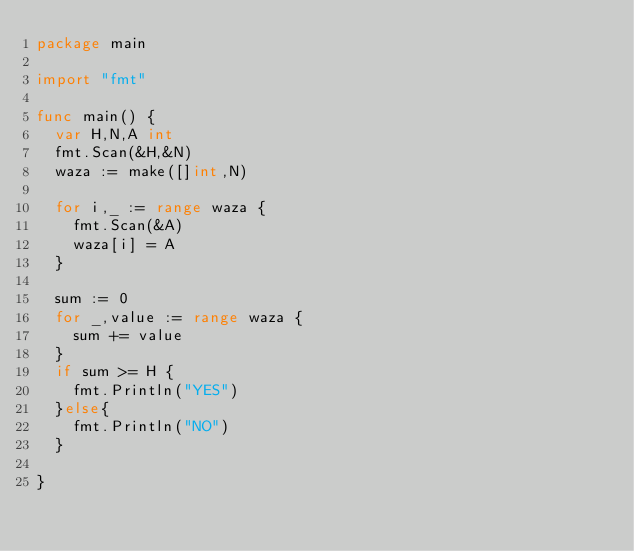<code> <loc_0><loc_0><loc_500><loc_500><_Go_>package main

import "fmt"

func main() {
	var H,N,A int
	fmt.Scan(&H,&N)
	waza := make([]int,N)

	for i,_ := range waza {
		fmt.Scan(&A)
		waza[i] = A
	}

	sum := 0
	for _,value := range waza {
		sum += value
	}
	if sum >= H {
		fmt.Println("YES")
	}else{
		fmt.Println("NO")
	}

}</code> 